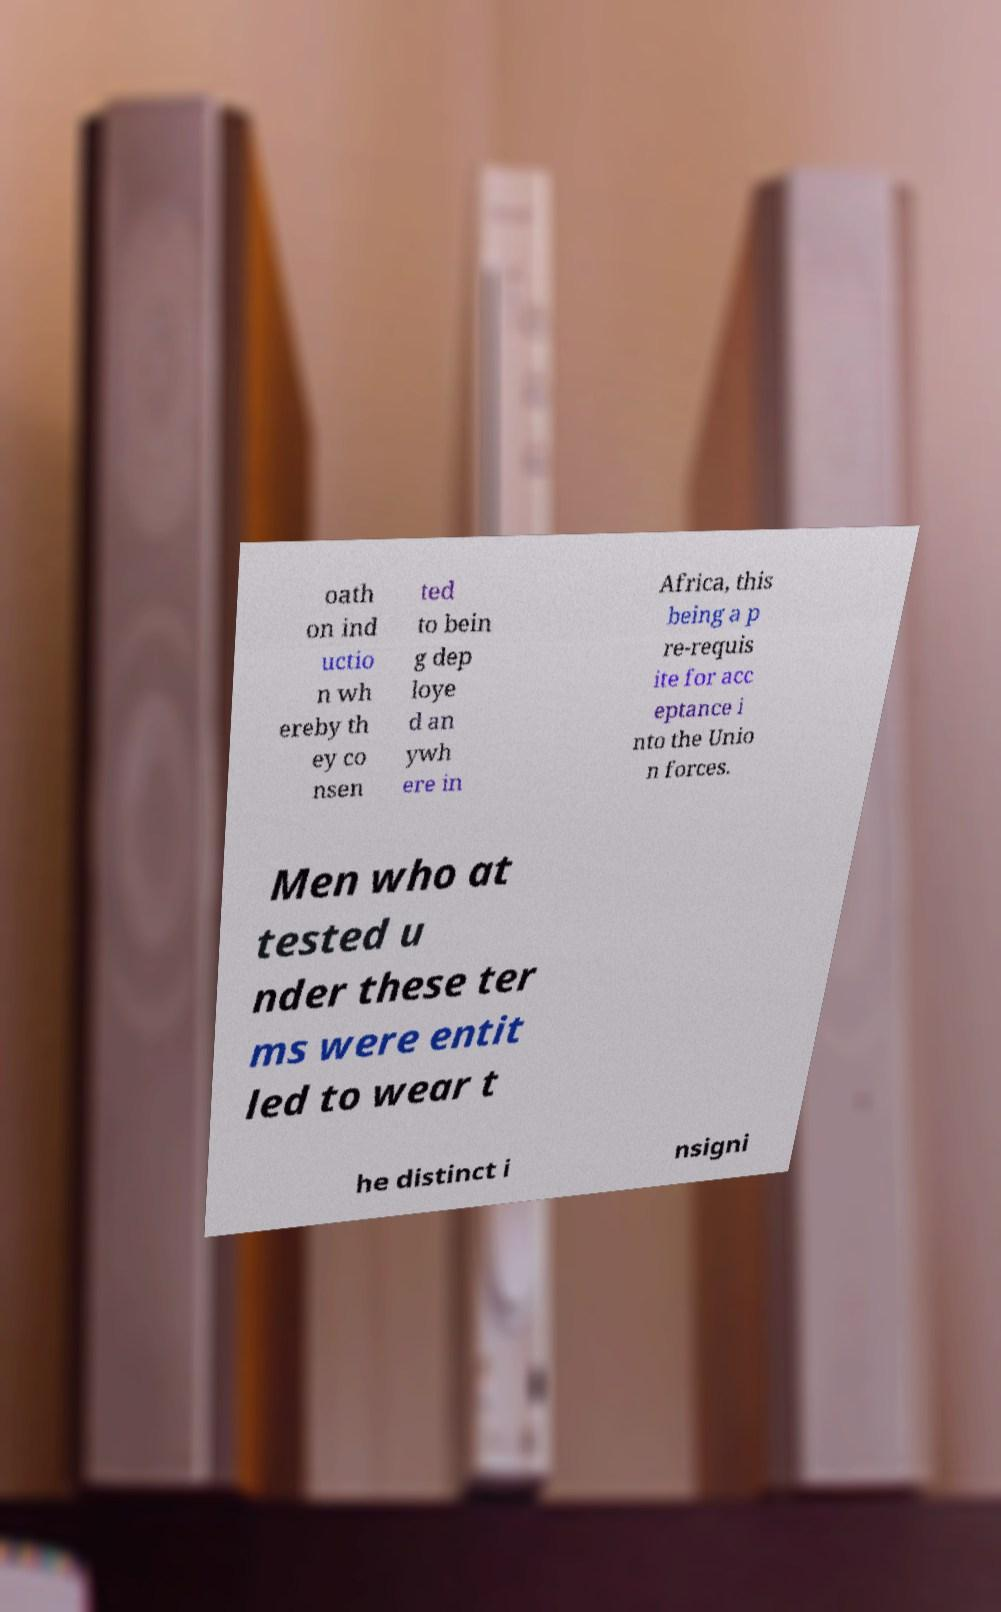What messages or text are displayed in this image? I need them in a readable, typed format. oath on ind uctio n wh ereby th ey co nsen ted to bein g dep loye d an ywh ere in Africa, this being a p re-requis ite for acc eptance i nto the Unio n forces. Men who at tested u nder these ter ms were entit led to wear t he distinct i nsigni 